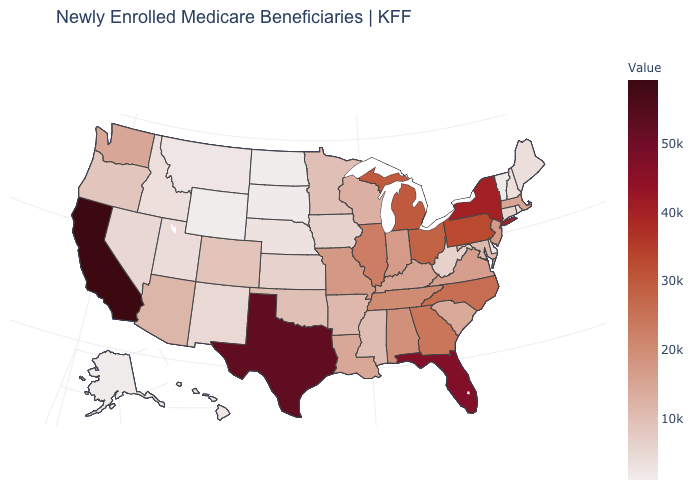Which states hav the highest value in the Northeast?
Write a very short answer. New York. Does California have the highest value in the West?
Quick response, please. Yes. Among the states that border Iowa , does Minnesota have the highest value?
Keep it brief. No. Which states hav the highest value in the MidWest?
Give a very brief answer. Michigan. Among the states that border Delaware , does Maryland have the lowest value?
Quick response, please. Yes. Does Tennessee have a higher value than Ohio?
Answer briefly. No. 